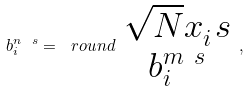<formula> <loc_0><loc_0><loc_500><loc_500>b _ { i } ^ { n \ s } = \ r o u n d { \begin{array} { c } \sqrt { N } x _ { i } ^ { \ } s \\ b _ { i } ^ { m \ s } \\ \end{array} } ,</formula> 